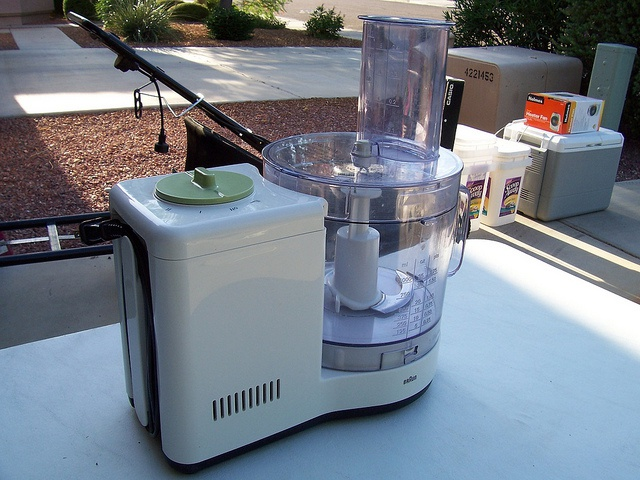Describe the objects in this image and their specific colors. I can see various objects in this image with different colors. 